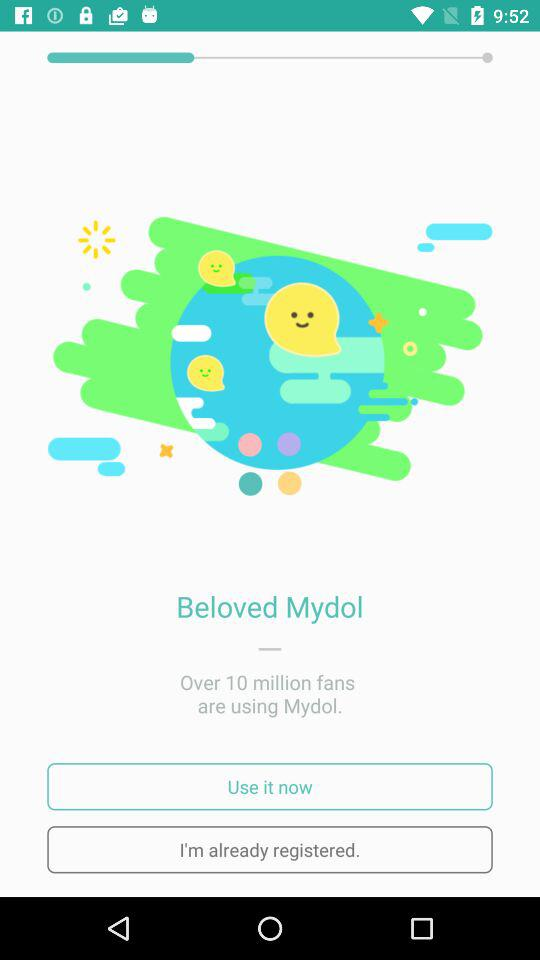What is the application name? The application name is "Mydol". 